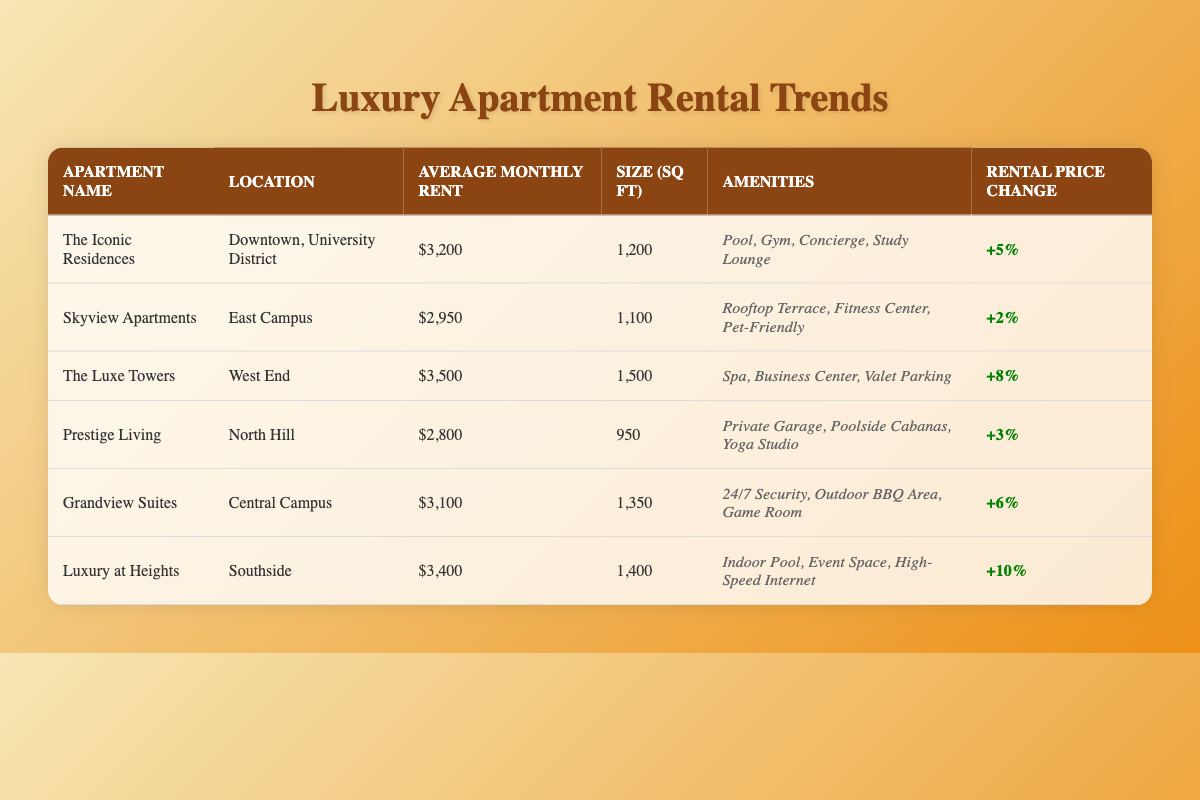What is the average monthly rent for "The Luxe Towers"? The table shows that "The Luxe Towers" has an average monthly rent of $3,500.
Answer: $3,500 How many square feet is the apartment "Grandview Suites"? The table lists "Grandview Suites" as having a size of 1,350 square feet.
Answer: 1,350 Which apartment has the highest rental price change last year? The table indicates that "Luxury at Heights" has the highest rental price change at +10%.
Answer: Luxury at Heights What is the combined average monthly rent of "Skyview Apartments" and "Prestige Living"? "Skyview Apartments" has an average rent of $2,950, and "Prestige Living" has $2,800. Adding these gives $2,950 + $2,800 = $5,750.
Answer: $5,750 Did "The Iconic Residences" see a rental price increase last year? The table shows a rental price change of +5%, which indicates it did see an increase.
Answer: Yes What is the average size of the apartments listed in the table? The sizes of the apartments are 1,200, 1,100, 1,500, 950, 1,350, and 1,400 square feet. The sum is 1,200 + 1,100 + 1,500 + 950 + 1,350 + 1,400 = 7,500. Dividing by 6 gives an average size of 7,500 / 6 = 1,250 square feet.
Answer: 1,250 Which apartment is located in "Downtown, University District"? The table lists "The Iconic Residences" as being located in "Downtown, University District".
Answer: The Iconic Residences How much more is the rent for "The Luxe Towers" compared to "Prestige Living"? "The Luxe Towers" rents for $3,500 and "Prestige Living" rents for $2,800. The difference is $3,500 - $2,800 = $700.
Answer: $700 Is there any apartment with a rental price change of 0% last year? The table shows that all listed apartments have a positive rental price change; therefore, none have 0%.
Answer: No What is the total rental price change for all the apartments combined? The individual price changes are +5, +2, +8, +3, +6, and +10. The total is 5 + 2 + 8 + 3 + 6 + 10 = 34%.
Answer: 34% 